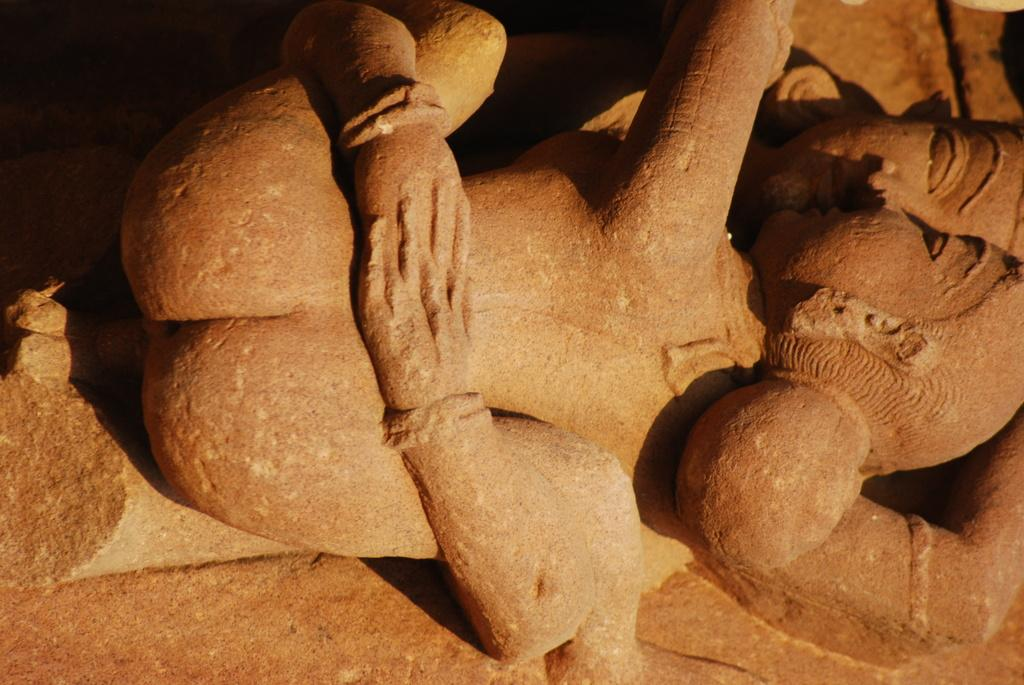What is the main subject of the image? There is a sculpture in the image. Where is the sculpture located? The sculpture is on a rock. What type of fork can be seen in the sculpture? There is no fork present in the sculpture or the image. 